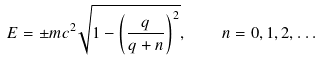<formula> <loc_0><loc_0><loc_500><loc_500>E = \pm m c ^ { 2 } \sqrt { 1 - \left ( \frac { q } { q + n } \right ) ^ { 2 } } , \quad n = 0 , 1 , 2 , \dots</formula> 